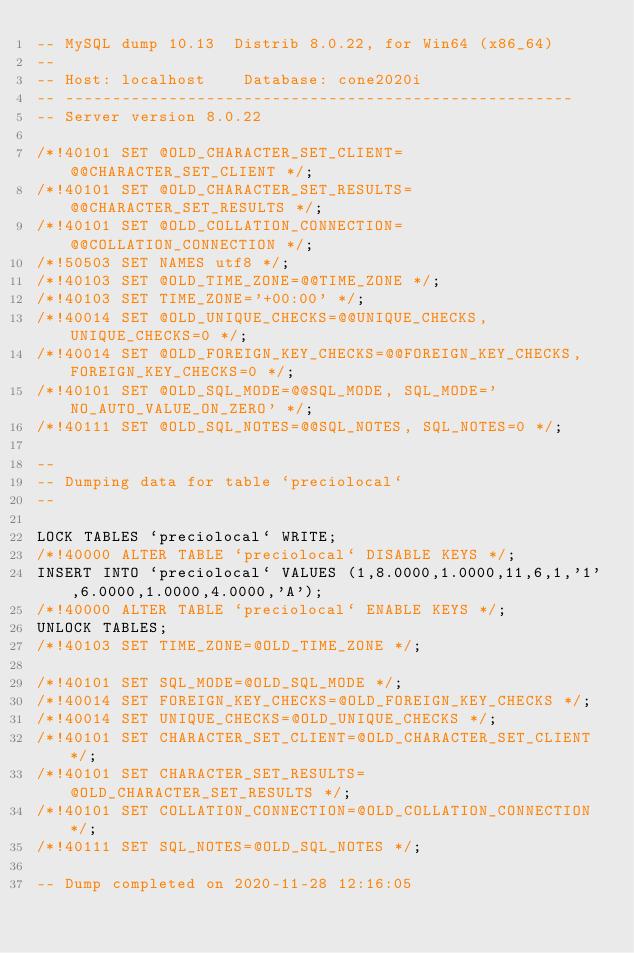Convert code to text. <code><loc_0><loc_0><loc_500><loc_500><_SQL_>-- MySQL dump 10.13  Distrib 8.0.22, for Win64 (x86_64)
--
-- Host: localhost    Database: cone2020i
-- ------------------------------------------------------
-- Server version	8.0.22

/*!40101 SET @OLD_CHARACTER_SET_CLIENT=@@CHARACTER_SET_CLIENT */;
/*!40101 SET @OLD_CHARACTER_SET_RESULTS=@@CHARACTER_SET_RESULTS */;
/*!40101 SET @OLD_COLLATION_CONNECTION=@@COLLATION_CONNECTION */;
/*!50503 SET NAMES utf8 */;
/*!40103 SET @OLD_TIME_ZONE=@@TIME_ZONE */;
/*!40103 SET TIME_ZONE='+00:00' */;
/*!40014 SET @OLD_UNIQUE_CHECKS=@@UNIQUE_CHECKS, UNIQUE_CHECKS=0 */;
/*!40014 SET @OLD_FOREIGN_KEY_CHECKS=@@FOREIGN_KEY_CHECKS, FOREIGN_KEY_CHECKS=0 */;
/*!40101 SET @OLD_SQL_MODE=@@SQL_MODE, SQL_MODE='NO_AUTO_VALUE_ON_ZERO' */;
/*!40111 SET @OLD_SQL_NOTES=@@SQL_NOTES, SQL_NOTES=0 */;

--
-- Dumping data for table `preciolocal`
--

LOCK TABLES `preciolocal` WRITE;
/*!40000 ALTER TABLE `preciolocal` DISABLE KEYS */;
INSERT INTO `preciolocal` VALUES (1,8.0000,1.0000,11,6,1,'1',6.0000,1.0000,4.0000,'A');
/*!40000 ALTER TABLE `preciolocal` ENABLE KEYS */;
UNLOCK TABLES;
/*!40103 SET TIME_ZONE=@OLD_TIME_ZONE */;

/*!40101 SET SQL_MODE=@OLD_SQL_MODE */;
/*!40014 SET FOREIGN_KEY_CHECKS=@OLD_FOREIGN_KEY_CHECKS */;
/*!40014 SET UNIQUE_CHECKS=@OLD_UNIQUE_CHECKS */;
/*!40101 SET CHARACTER_SET_CLIENT=@OLD_CHARACTER_SET_CLIENT */;
/*!40101 SET CHARACTER_SET_RESULTS=@OLD_CHARACTER_SET_RESULTS */;
/*!40101 SET COLLATION_CONNECTION=@OLD_COLLATION_CONNECTION */;
/*!40111 SET SQL_NOTES=@OLD_SQL_NOTES */;

-- Dump completed on 2020-11-28 12:16:05
</code> 